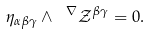<formula> <loc_0><loc_0><loc_500><loc_500>\eta _ { \alpha \beta \gamma } \wedge \ ^ { \nabla } \mathcal { Z } _ { \ } ^ { \beta \gamma } = 0 .</formula> 